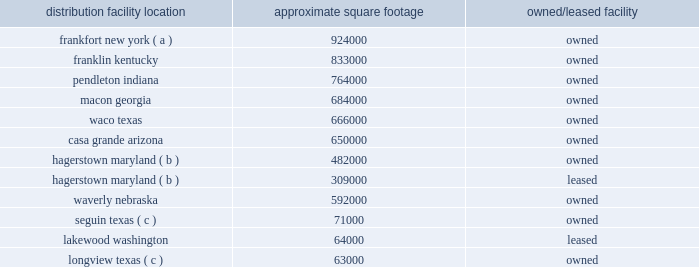The following is a list of distribution locations including the approximate square footage and if the location is leased or owned: .
Longview , texas ( c ) 63000 owned ( a ) the frankfort , new york , distribution center began receiving merchandise in fourth quarter of fiscal 2018 , and is expected to begin shipping merchandise to stores in the first quarter of fiscal 2019 .
( b ) the leased distribution center in hagerstown is treated as an extension of the existing owned hagerstown location and is not considered a separate distribution center .
( c ) this is a mixing center designed to process certain high-volume bulk products .
The company 2019s store support center occupies approximately 260000 square feet of owned building space in brentwood , tennessee , and the company 2019s merchandising innovation center occupies approximately 32000 square feet of leased building space in nashville , tennessee .
The company also leases approximately 8000 square feet of building space for the petsense corporate headquarters , located in scottsdale , arizona .
Item 3 .
Legal proceedings the company is involved in various litigation matters arising in the ordinary course of business .
The company believes that any estimated loss related to such matters has been adequately provided for in accrued liabilities to the extent probable and reasonably estimable .
Accordingly , the company currently expects these matters will be resolved without material adverse effect on its consolidated financial position , results of operations or cash flows .
Item 4 .
Mine safety disclosures not applicable. .
What is the total leased property square footage? 
Computations: (309000 + 64000)
Answer: 373000.0. 